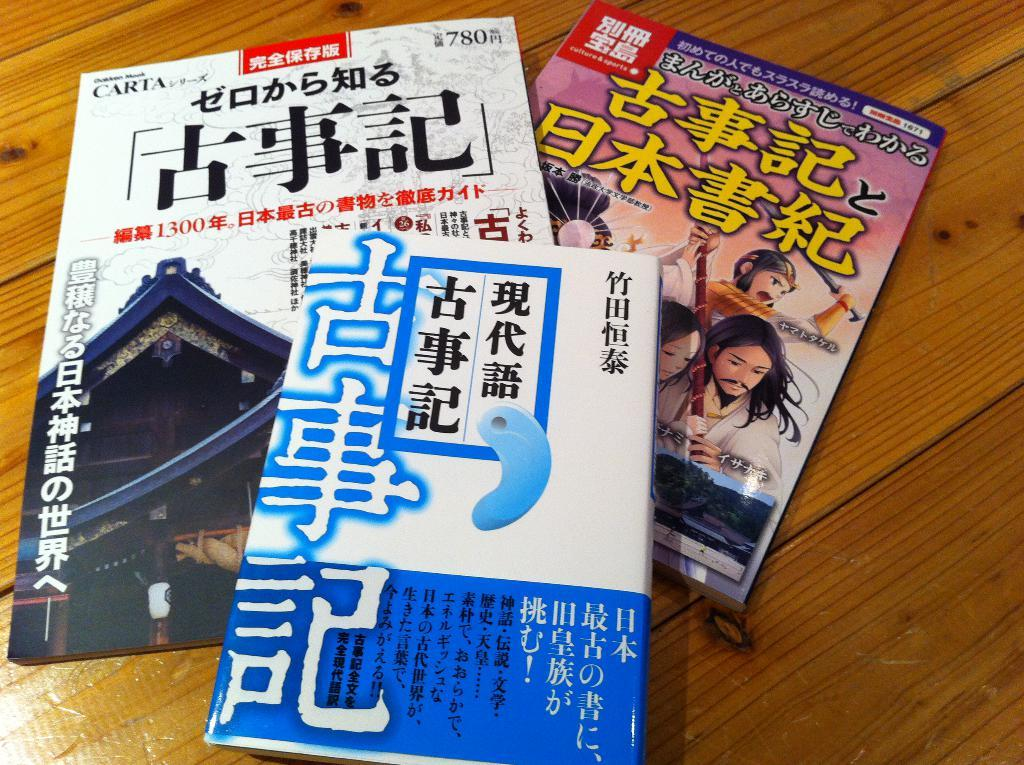<image>
Provide a brief description of the given image. A stack of books with Japanese characters written on them 